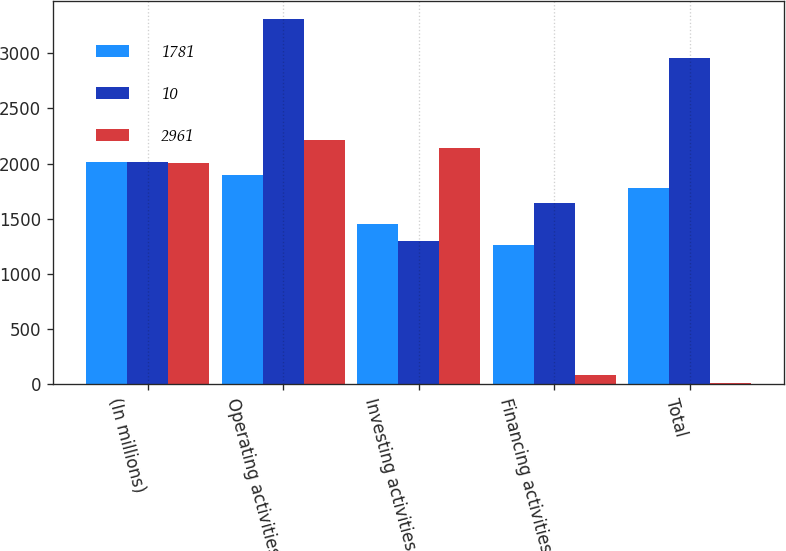<chart> <loc_0><loc_0><loc_500><loc_500><stacked_bar_chart><ecel><fcel>(In millions)<fcel>Operating activities<fcel>Investing activities<fcel>Financing activities<fcel>Total<nl><fcel>1781<fcel>2012<fcel>1895.5<fcel>1452<fcel>1259<fcel>1781<nl><fcel>10<fcel>2011<fcel>3309<fcel>1295<fcel>1643<fcel>2961<nl><fcel>2961<fcel>2010<fcel>2217<fcel>2145<fcel>82<fcel>10<nl></chart> 